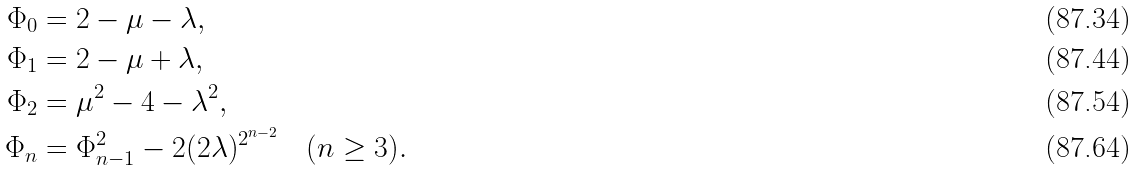Convert formula to latex. <formula><loc_0><loc_0><loc_500><loc_500>\Phi _ { 0 } & = 2 - \mu - \lambda , \\ \Phi _ { 1 } & = 2 - \mu + \lambda , \\ \Phi _ { 2 } & = \mu ^ { 2 } - 4 - \lambda ^ { 2 } , \\ \Phi _ { n } & = \Phi _ { n - 1 } ^ { 2 } - 2 ( 2 \lambda ) ^ { 2 ^ { n - 2 } } \quad ( n \geq 3 ) .</formula> 